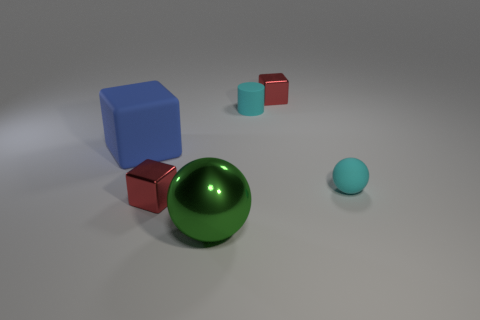The thing that is behind the small sphere and to the left of the metal sphere has what shape?
Your answer should be very brief. Cube. The cyan cylinder that is the same material as the big blue thing is what size?
Provide a succinct answer. Small. Is the color of the small matte cylinder the same as the sphere right of the cyan cylinder?
Give a very brief answer. Yes. There is a small object that is in front of the large blue matte thing and to the right of the big shiny thing; what material is it?
Ensure brevity in your answer.  Rubber. What is the size of the ball that is the same color as the cylinder?
Offer a very short reply. Small. There is a tiny shiny thing left of the green thing; is it the same shape as the red thing behind the blue rubber thing?
Ensure brevity in your answer.  Yes. Are there any big blue shiny things?
Give a very brief answer. No. What is the color of the matte cylinder that is the same size as the cyan ball?
Your response must be concise. Cyan. Do the big green sphere and the blue object have the same material?
Provide a short and direct response. No. How many large matte blocks have the same color as the small cylinder?
Keep it short and to the point. 0. 